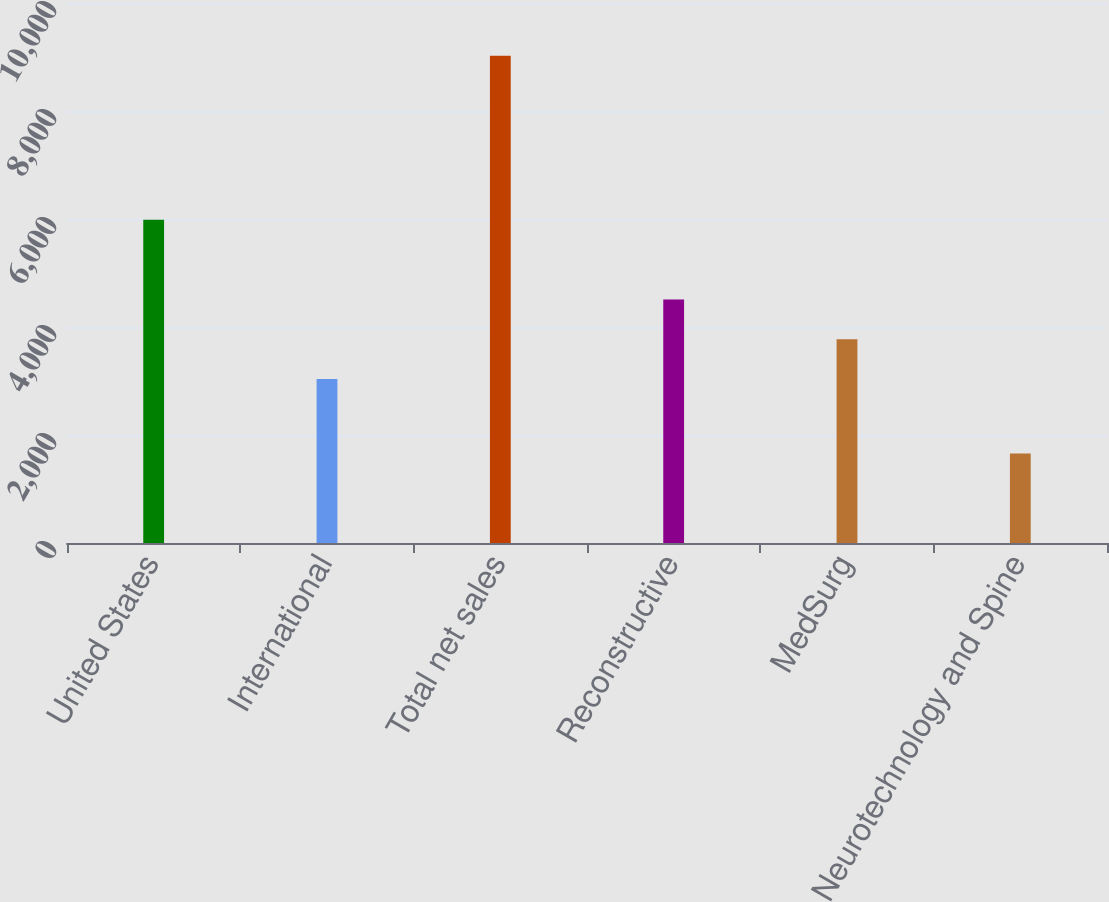Convert chart to OTSL. <chart><loc_0><loc_0><loc_500><loc_500><bar_chart><fcel>United States<fcel>International<fcel>Total net sales<fcel>Reconstructive<fcel>MedSurg<fcel>Neurotechnology and Spine<nl><fcel>5984<fcel>3037<fcel>9021<fcel>4509.6<fcel>3773.3<fcel>1658<nl></chart> 